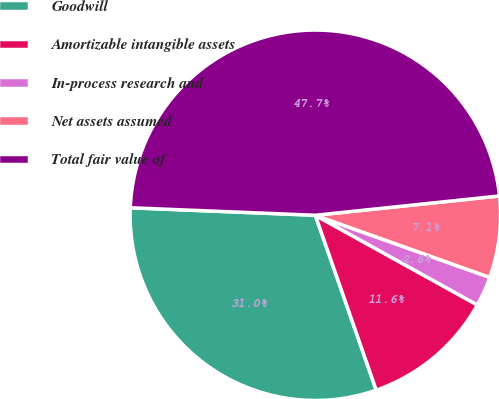<chart> <loc_0><loc_0><loc_500><loc_500><pie_chart><fcel>Goodwill<fcel>Amortizable intangible assets<fcel>In-process research and<fcel>Net assets assumed<fcel>Total fair value of<nl><fcel>30.98%<fcel>11.62%<fcel>2.6%<fcel>7.11%<fcel>47.69%<nl></chart> 